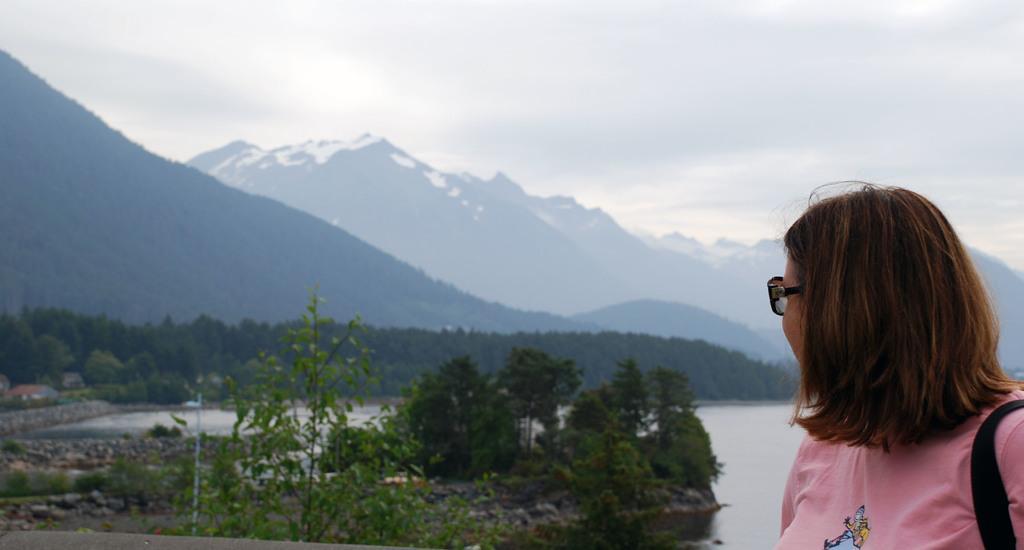Can you describe this image briefly? In this image I can see a woman on the right side and I can see she is wearing pink colour dress and a specs. I can also see a black colour thing on her shoulder. In the background I can see number of trees, few buildings, mountains and the sky. 